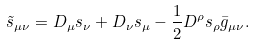<formula> <loc_0><loc_0><loc_500><loc_500>\tilde { s } _ { \mu \nu } = D _ { \mu } s _ { \nu } + D _ { \nu } s _ { \mu } - \frac { 1 } { 2 } D ^ { \rho } s _ { \rho } \bar { g } _ { \mu \nu } .</formula> 